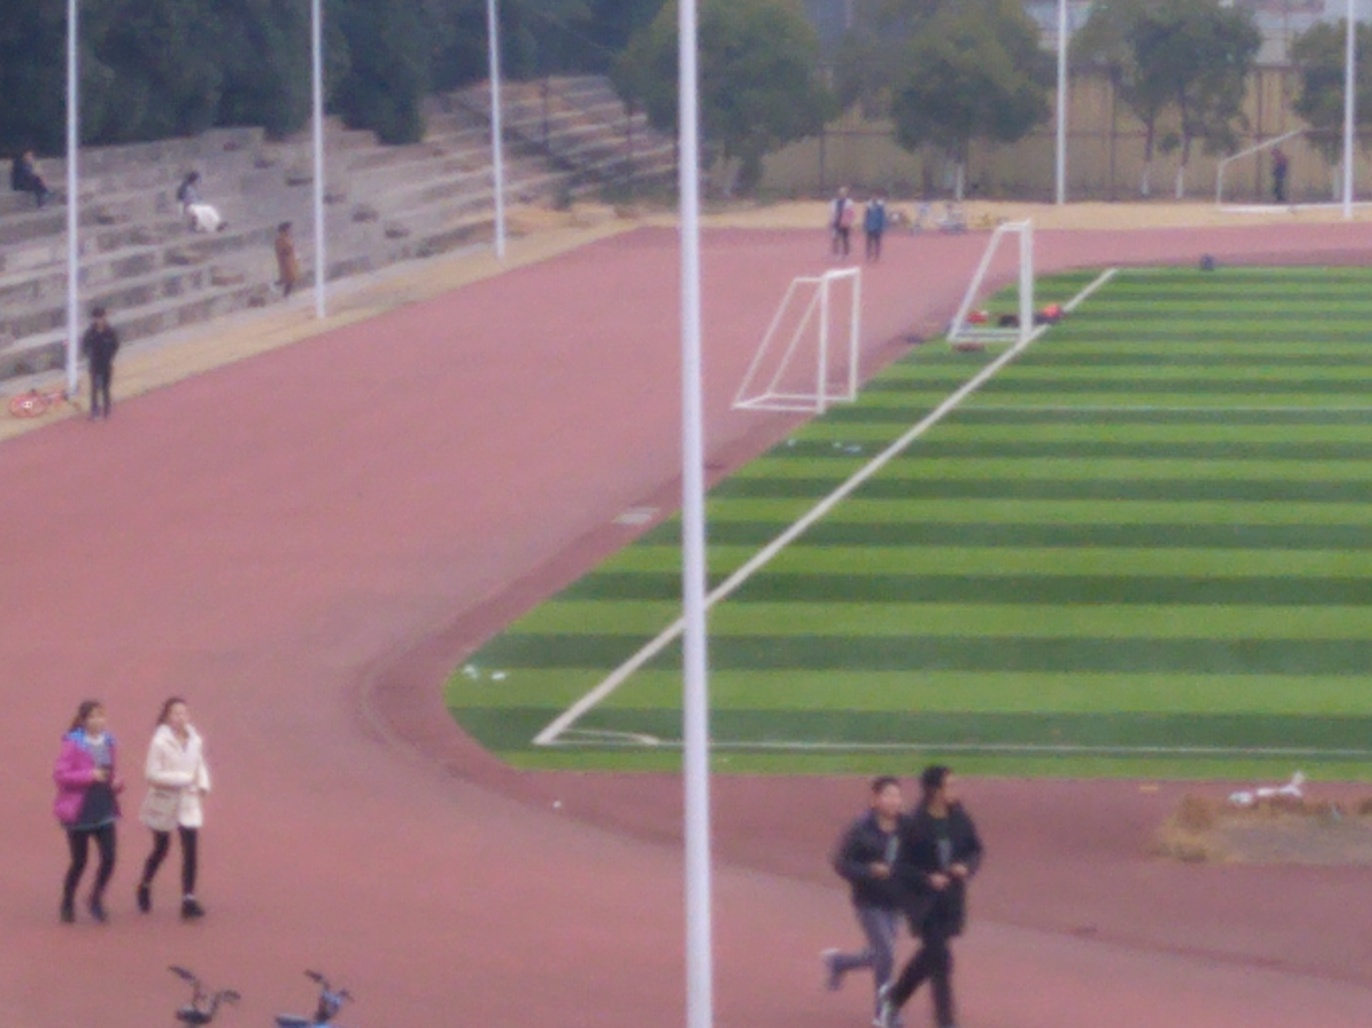Is this photo taken during a specific time of day? The lighting in the photo suggests it might be taken in the late afternoon, as the shadows are somewhat elongated but not overly so, indicating the sun is not yet near the horizon. 